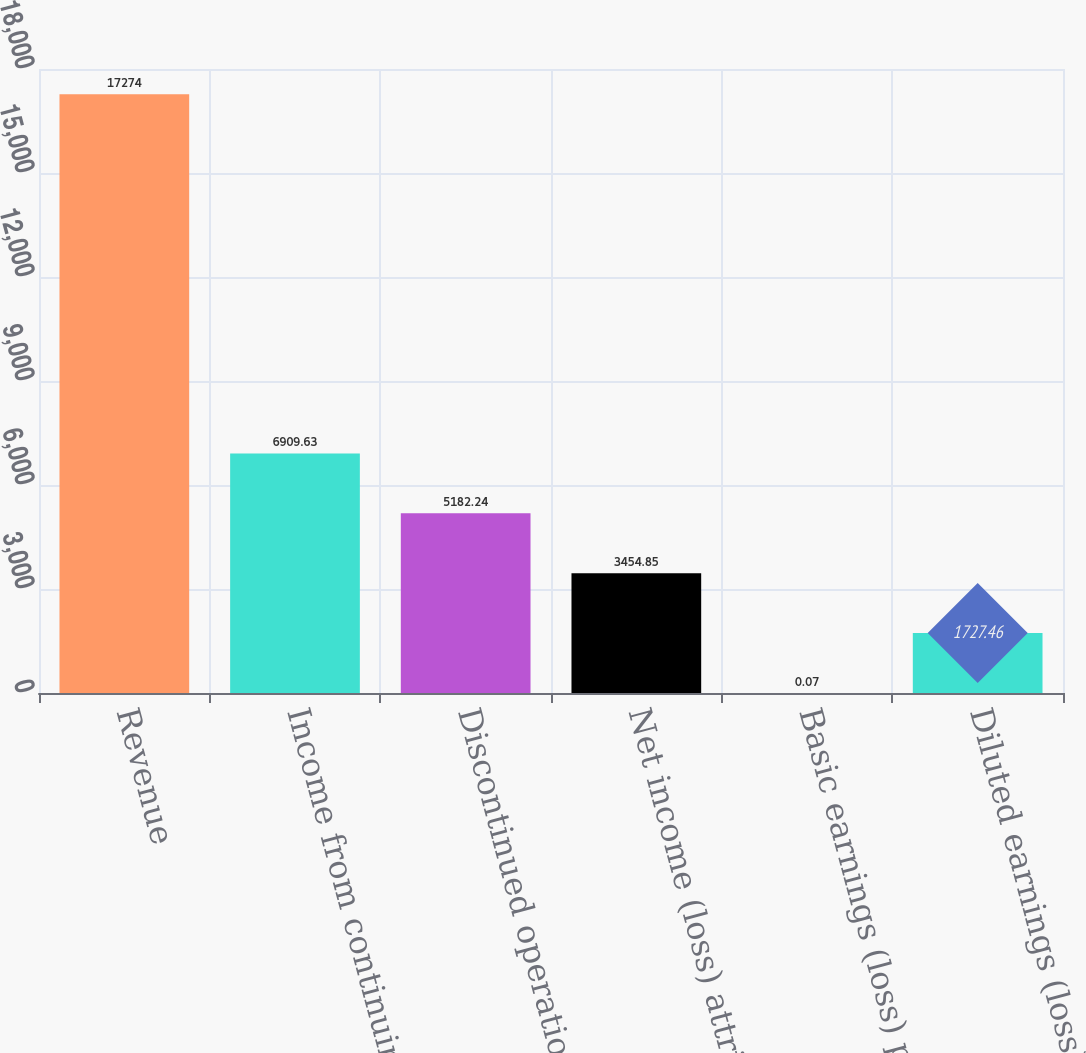<chart> <loc_0><loc_0><loc_500><loc_500><bar_chart><fcel>Revenue<fcel>Income from continuing<fcel>Discontinued operations net of<fcel>Net income (loss) attributable<fcel>Basic earnings (loss) per<fcel>Diluted earnings (loss) per<nl><fcel>17274<fcel>6909.63<fcel>5182.24<fcel>3454.85<fcel>0.07<fcel>1727.46<nl></chart> 